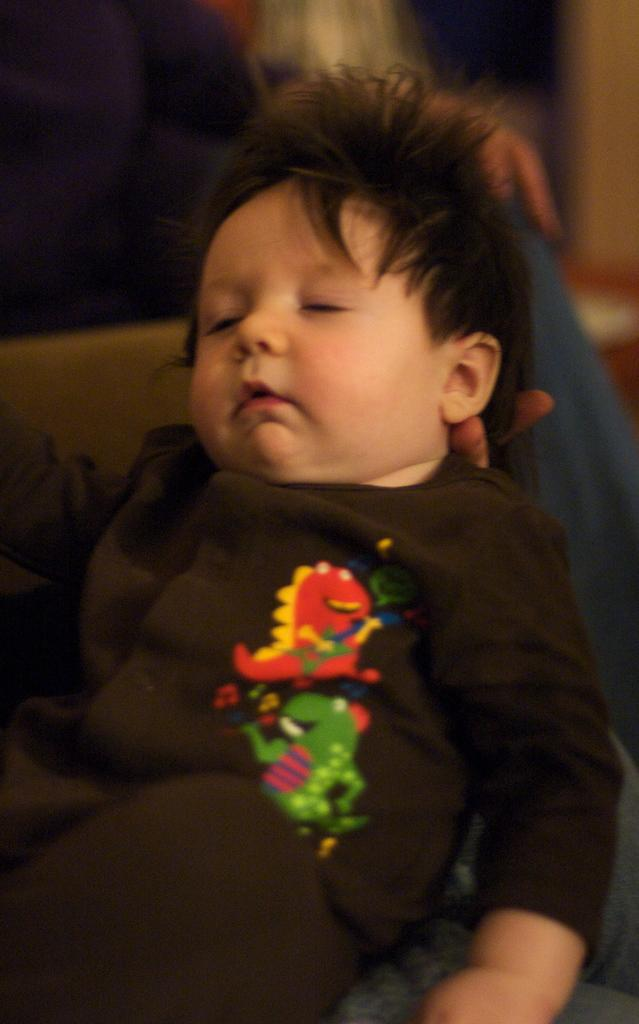What is the main subject of the image? The main subject of the image is a baby sleeping. Can you describe the baby's clothing? The baby is wearing a black dress with a design. Who is holding the baby? A person is holding the baby. Are there any other people visible in the image? Yes, there is another person in the background of the image. What type of flowers can be seen growing in the playground in the image? There is no playground or flowers present in the image; it features a baby sleeping while being held by a person. 